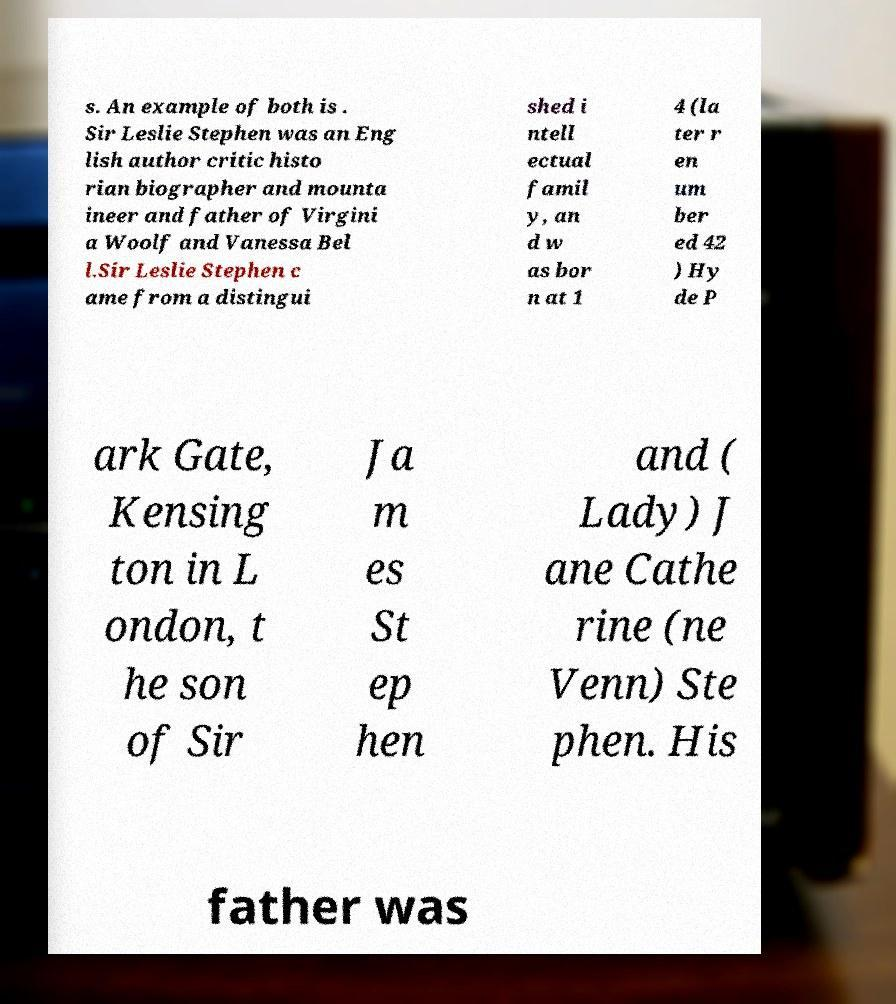There's text embedded in this image that I need extracted. Can you transcribe it verbatim? s. An example of both is . Sir Leslie Stephen was an Eng lish author critic histo rian biographer and mounta ineer and father of Virgini a Woolf and Vanessa Bel l.Sir Leslie Stephen c ame from a distingui shed i ntell ectual famil y, an d w as bor n at 1 4 (la ter r en um ber ed 42 ) Hy de P ark Gate, Kensing ton in L ondon, t he son of Sir Ja m es St ep hen and ( Lady) J ane Cathe rine (ne Venn) Ste phen. His father was 